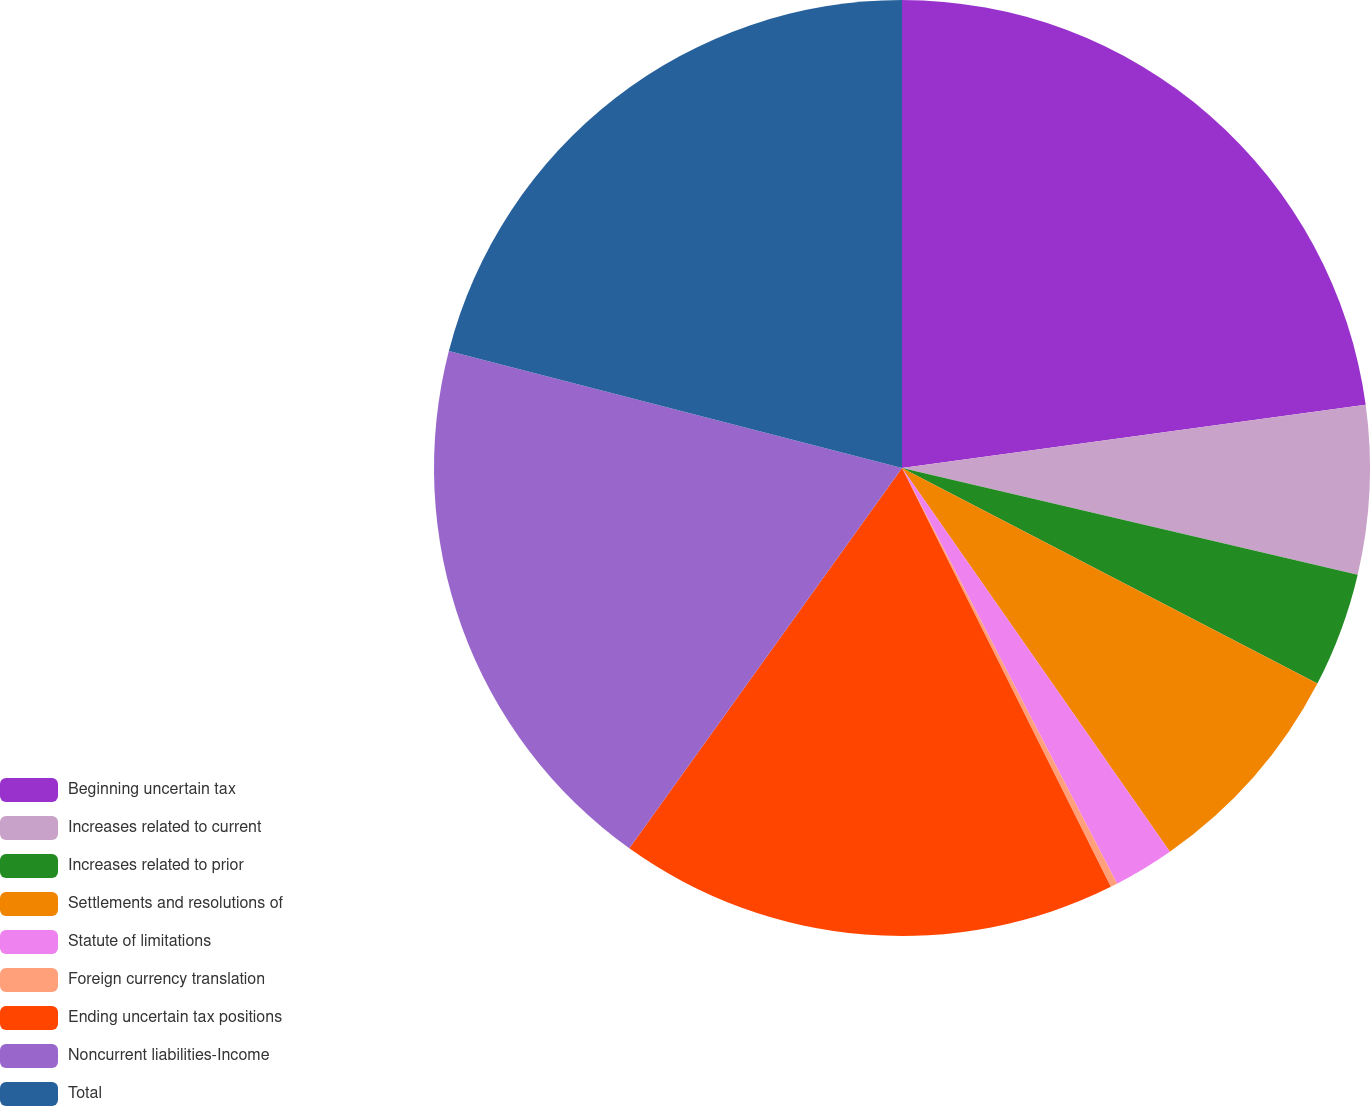Convert chart. <chart><loc_0><loc_0><loc_500><loc_500><pie_chart><fcel>Beginning uncertain tax<fcel>Increases related to current<fcel>Increases related to prior<fcel>Settlements and resolutions of<fcel>Statute of limitations<fcel>Foreign currency translation<fcel>Ending uncertain tax positions<fcel>Noncurrent liabilities-Income<fcel>Total<nl><fcel>22.84%<fcel>5.82%<fcel>3.96%<fcel>7.68%<fcel>2.1%<fcel>0.24%<fcel>17.26%<fcel>19.12%<fcel>20.98%<nl></chart> 